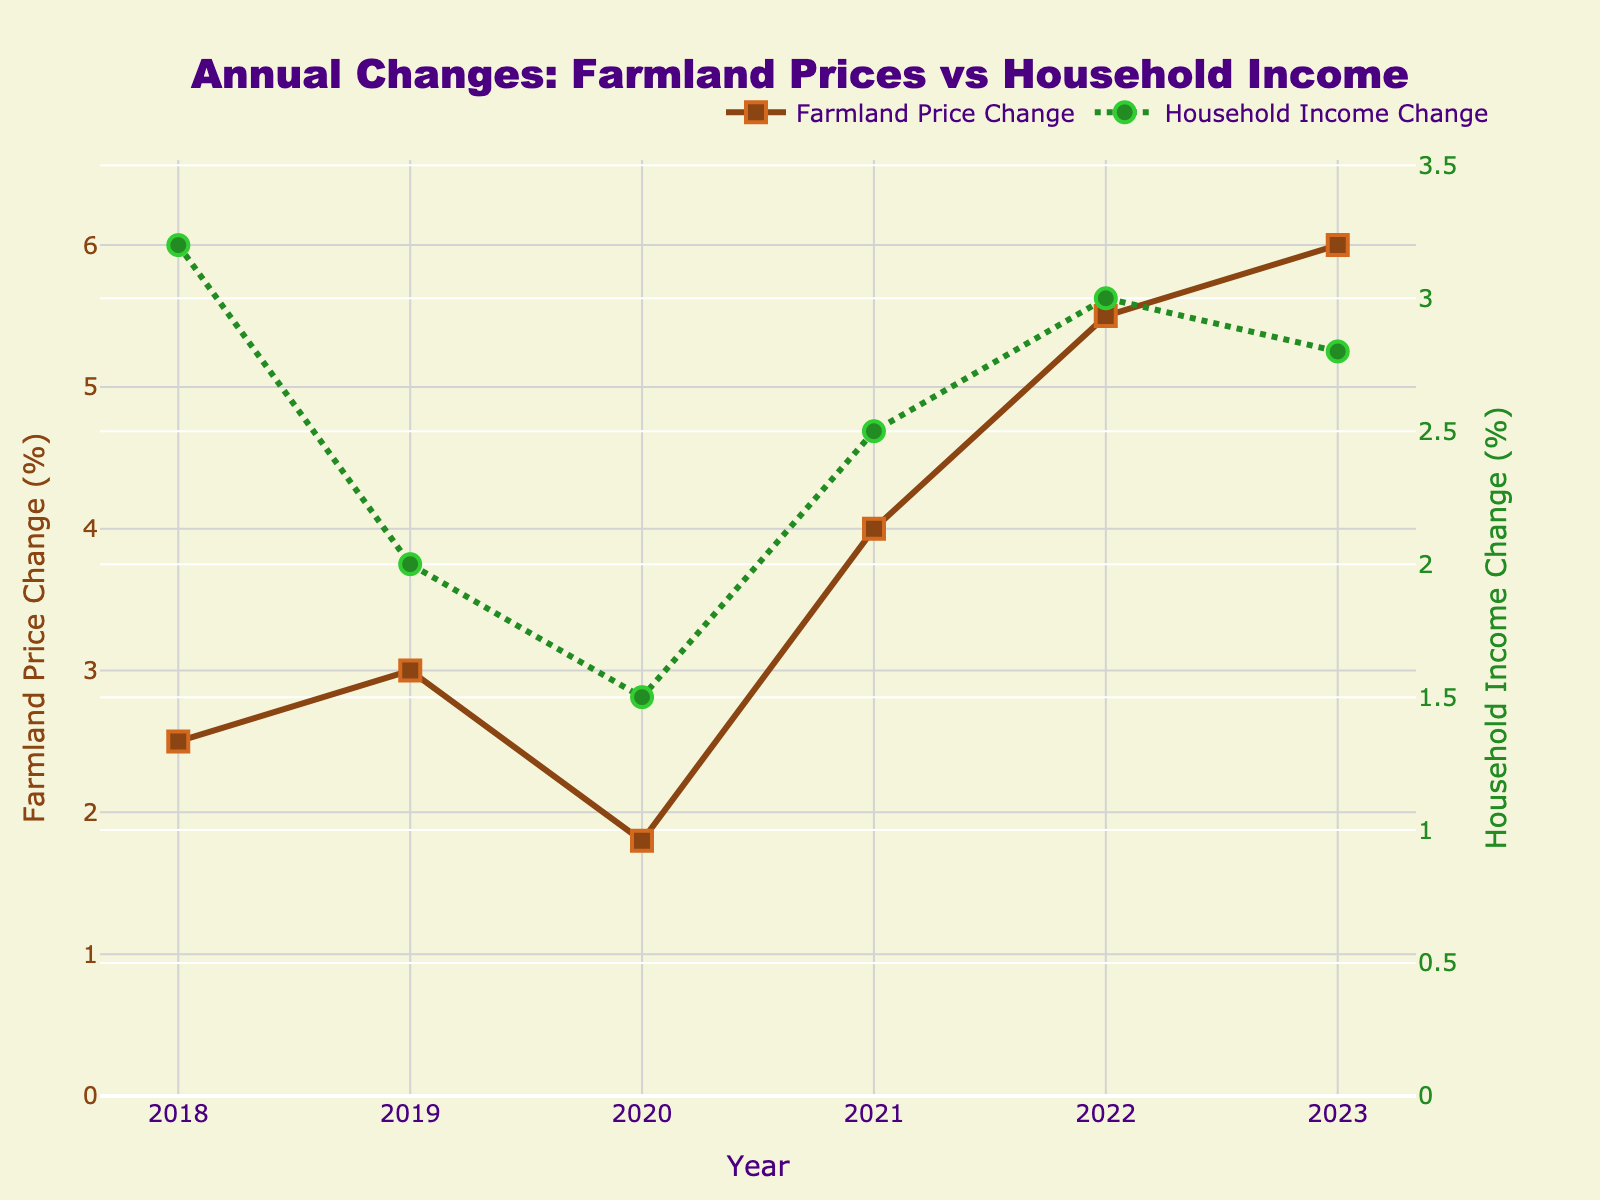How many years are displayed in the figure? The x-axis shows annual data points from the year 2018 to 2023. Counting these individual data points results in a total of 6 years.
Answer: 6 What is the title of the figure? The title of the figure is located at the top of the chart and reads "Annual Changes: Farmland Prices vs Household Income."
Answer: Annual Changes: Farmland Prices vs Household Income What was the farmland price change percentage in 2021? Look at the solid brown line (Farmland Price Change) at the position associated with the year 2021 on the x-axis. The marker in 2021 corresponds to approximately 4.0% on the left y-axis.
Answer: 4.0% How does the household income change in 2023 compare to 2020? Locate both years on the chart and refer to the green dotted line (Household Income Change). The income change percentage is approximately 2.8% in 2023 and 1.5% in 2020. Subtracting these gives 2.8% - 1.5% = 1.3%.
Answer: 1.3% In which year did the household income change percentage reach its highest value? Examine the green dotted line and find its peak value. This peak appears to be in the year 2018 with a percentage of 3.2%.
Answer: 2018 Was there any year when the farmland price change percentage was lower than the household income change percentage? Compare the lines year by year. In 2018, the farmland price change percentage (2.5%) is lower than the household income change percentage (3.2%).
Answer: Yes, in 2018 In what year did both the farmland price and household income change percentages increase the most compared to the previous year? Check the differences year by year. Both experienced the highest increase from 2021 to 2022. Farmland price from 4.0% to 5.5% (increase of 1.5%) and household income from 2.5% to 3.0% (increase of 0.5%).
Answer: 2022 What is the difference in farmland price change percentage between 2019 and 2022? The farmland price change percentage in 2019 is 3.0%, and in 2022 it is 5.5%. The difference is calculated as 5.5% - 3.0% = 2.5%.
Answer: 2.5% What are the colors used for depicting farmland prices and household income changes? The figure uses brown (or dark brown) for farmland prices and green for household income changes.
Answer: Brown and Green 